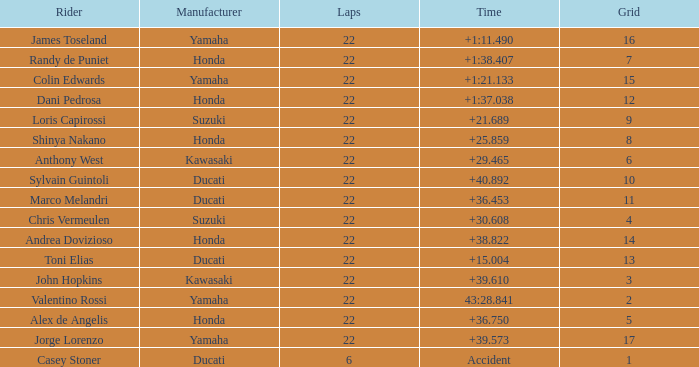Could you parse the entire table? {'header': ['Rider', 'Manufacturer', 'Laps', 'Time', 'Grid'], 'rows': [['James Toseland', 'Yamaha', '22', '+1:11.490', '16'], ['Randy de Puniet', 'Honda', '22', '+1:38.407', '7'], ['Colin Edwards', 'Yamaha', '22', '+1:21.133', '15'], ['Dani Pedrosa', 'Honda', '22', '+1:37.038', '12'], ['Loris Capirossi', 'Suzuki', '22', '+21.689', '9'], ['Shinya Nakano', 'Honda', '22', '+25.859', '8'], ['Anthony West', 'Kawasaki', '22', '+29.465', '6'], ['Sylvain Guintoli', 'Ducati', '22', '+40.892', '10'], ['Marco Melandri', 'Ducati', '22', '+36.453', '11'], ['Chris Vermeulen', 'Suzuki', '22', '+30.608', '4'], ['Andrea Dovizioso', 'Honda', '22', '+38.822', '14'], ['Toni Elias', 'Ducati', '22', '+15.004', '13'], ['John Hopkins', 'Kawasaki', '22', '+39.610', '3'], ['Valentino Rossi', 'Yamaha', '22', '43:28.841', '2'], ['Alex de Angelis', 'Honda', '22', '+36.750', '5'], ['Jorge Lorenzo', 'Yamaha', '22', '+39.573', '17'], ['Casey Stoner', 'Ducati', '6', 'Accident', '1']]} What laps did Honda do with a time of +1:38.407? 22.0. 